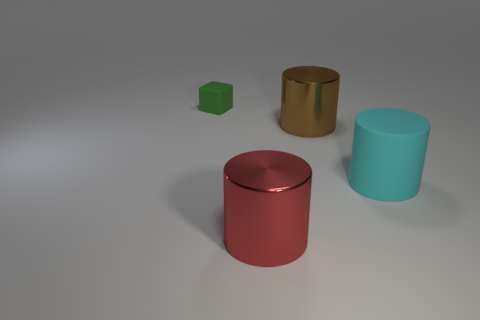Are there any large red things to the left of the green object?
Make the answer very short. No. How many rubber objects are either tiny purple things or large cylinders?
Provide a succinct answer. 1. What number of large brown shiny cylinders are left of the big brown object?
Your response must be concise. 0. Are there any rubber cylinders that have the same size as the cyan rubber object?
Keep it short and to the point. No. Is there another tiny rubber object that has the same color as the tiny object?
Provide a short and direct response. No. Is there any other thing that is the same size as the cube?
Ensure brevity in your answer.  No. How many things have the same color as the tiny rubber block?
Give a very brief answer. 0. Does the small matte thing have the same color as the big metallic object that is in front of the brown thing?
Give a very brief answer. No. How many things are either red cubes or objects right of the tiny thing?
Your response must be concise. 3. There is a cylinder that is in front of the cylinder right of the big brown shiny cylinder; what size is it?
Make the answer very short. Large. 